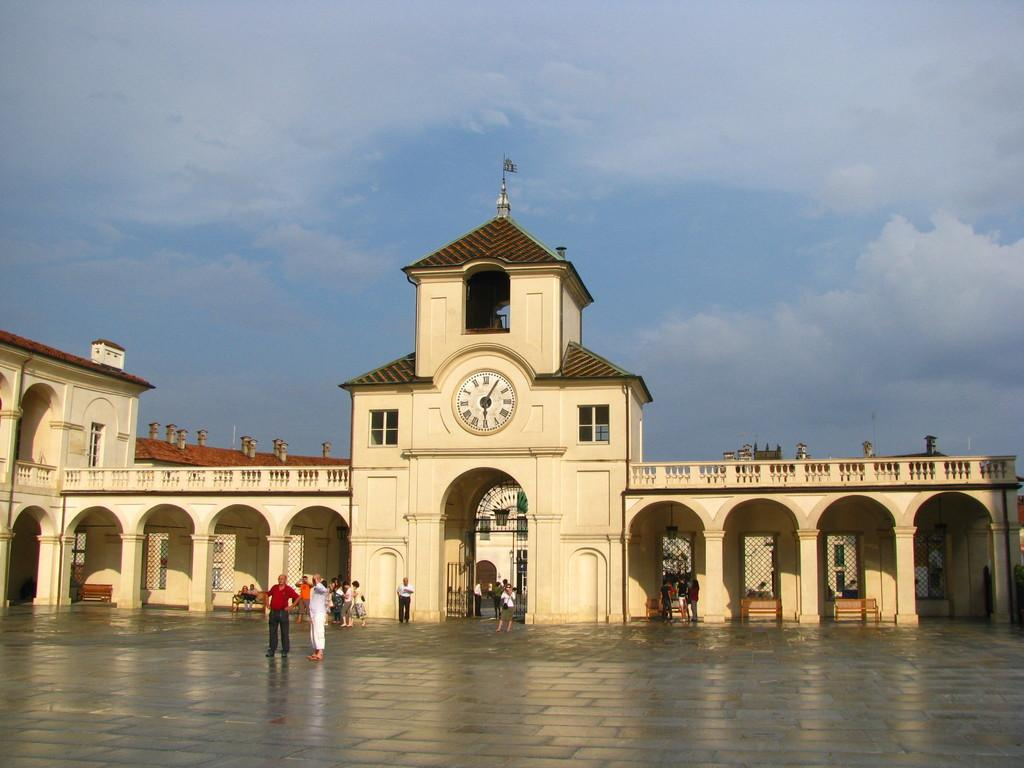What type of structure is visible in the image? There is a building in the image. Who or what can be seen in the image besides the building? There are people and chairs visible in the image. What else is present in the image besides people and chairs? Other objects are visible in the image. Where is the floor located in the image? The floor is at the bottom of the image. What is visible at the top of the image? The sky is at the top of the image. What type of cloth is being discussed by the committee in the image? There is no committee or cloth mentioned or visible in the image. 